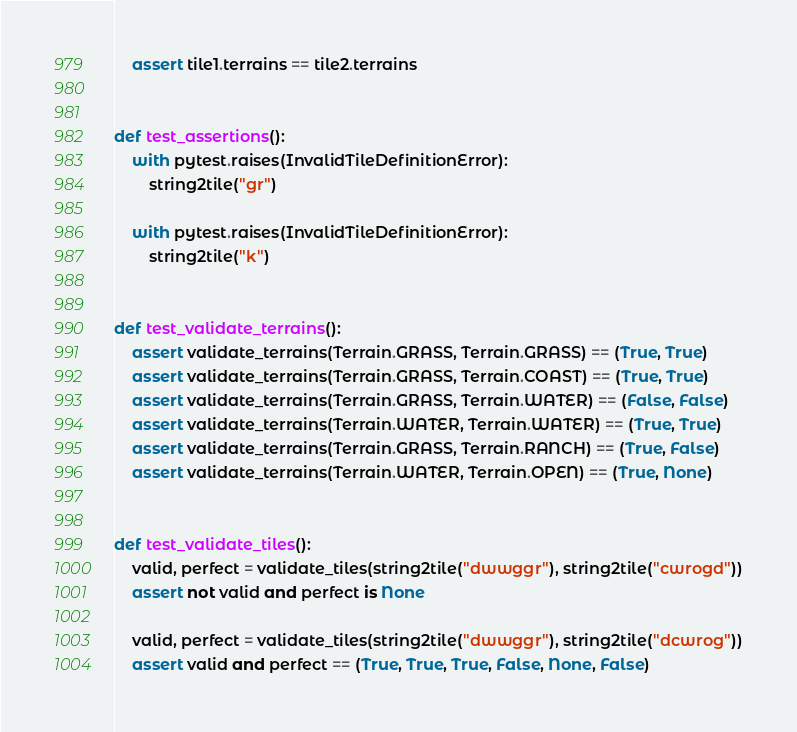<code> <loc_0><loc_0><loc_500><loc_500><_Python_>    assert tile1.terrains == tile2.terrains


def test_assertions():
    with pytest.raises(InvalidTileDefinitionError):
        string2tile("gr")

    with pytest.raises(InvalidTileDefinitionError):
        string2tile("k")


def test_validate_terrains():
    assert validate_terrains(Terrain.GRASS, Terrain.GRASS) == (True, True)
    assert validate_terrains(Terrain.GRASS, Terrain.COAST) == (True, True)
    assert validate_terrains(Terrain.GRASS, Terrain.WATER) == (False, False)
    assert validate_terrains(Terrain.WATER, Terrain.WATER) == (True, True)
    assert validate_terrains(Terrain.GRASS, Terrain.RANCH) == (True, False)
    assert validate_terrains(Terrain.WATER, Terrain.OPEN) == (True, None)


def test_validate_tiles():
    valid, perfect = validate_tiles(string2tile("dwwggr"), string2tile("cwrogd"))
    assert not valid and perfect is None

    valid, perfect = validate_tiles(string2tile("dwwggr"), string2tile("dcwrog"))
    assert valid and perfect == (True, True, True, False, None, False)
</code> 